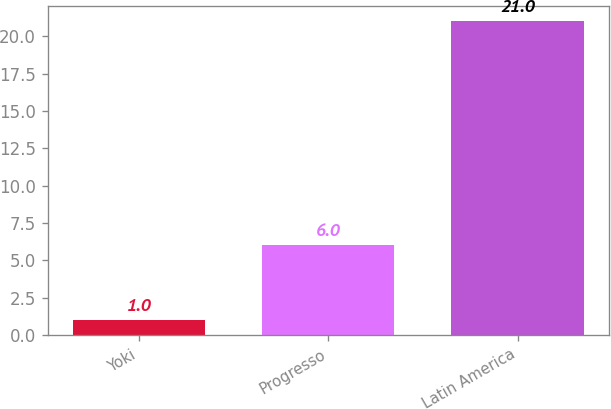Convert chart to OTSL. <chart><loc_0><loc_0><loc_500><loc_500><bar_chart><fcel>Yoki<fcel>Progresso<fcel>Latin America<nl><fcel>1<fcel>6<fcel>21<nl></chart> 